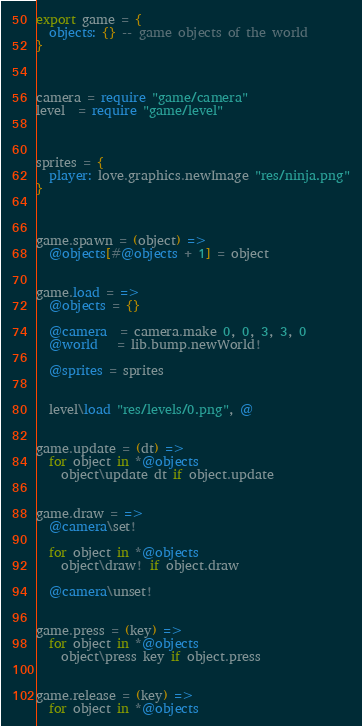<code> <loc_0><loc_0><loc_500><loc_500><_MoonScript_>export game = {
  objects: {} -- game objects of the world
}



camera = require "game/camera"
level  = require "game/level"



sprites = {
  player: love.graphics.newImage "res/ninja.png"
}



game.spawn = (object) =>
  @objects[#@objects + 1] = object


game.load = =>
  @objects = {}

  @camera  = camera.make 0, 0, 3, 3, 0
  @world   = lib.bump.newWorld!

  @sprites = sprites


  level\load "res/levels/0.png", @


game.update = (dt) =>
  for object in *@objects
    object\update dt if object.update


game.draw = =>
  @camera\set!

  for object in *@objects
    object\draw! if object.draw

  @camera\unset!


game.press = (key) =>
  for object in *@objects
    object\press key if object.press


game.release = (key) =>
  for object in *@objects</code> 